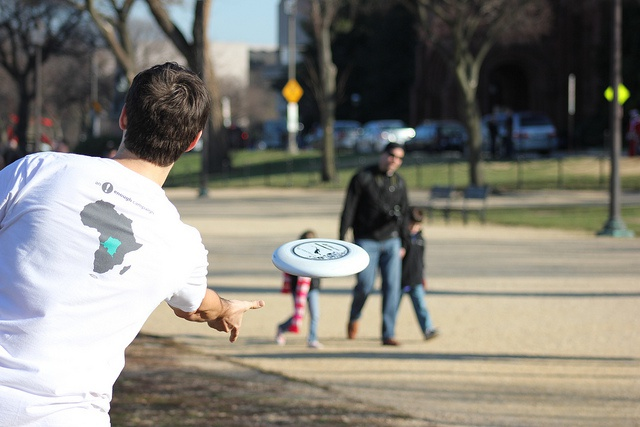Describe the objects in this image and their specific colors. I can see people in purple, white, black, and darkgray tones, people in purple, black, and gray tones, frisbee in purple, white, lightblue, darkgray, and gray tones, people in purple, black, gray, darkblue, and darkgray tones, and people in purple, gray, darkgray, lightpink, and black tones in this image. 